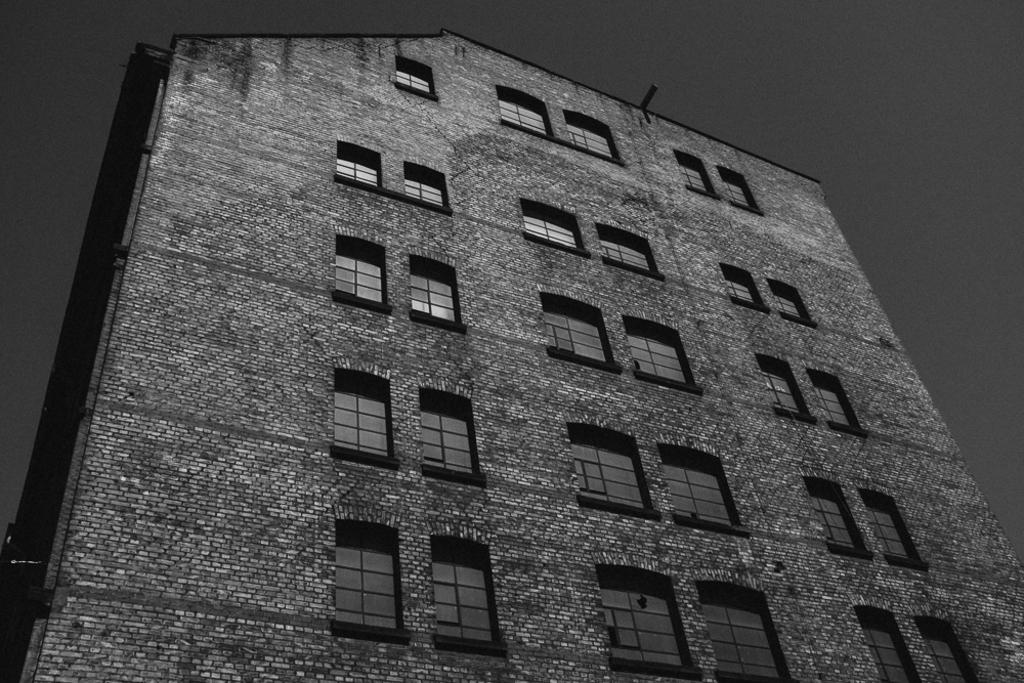What is the main subject of the image? The main subject of the image is a building. What feature of the building is mentioned in the facts? The building has many windows. What part of the natural environment is visible in the image? The sky is visible in the top right corner of the image. What rate do the dolls in the image move at? There are no dolls present in the image, so there is no rate at which they would move. 